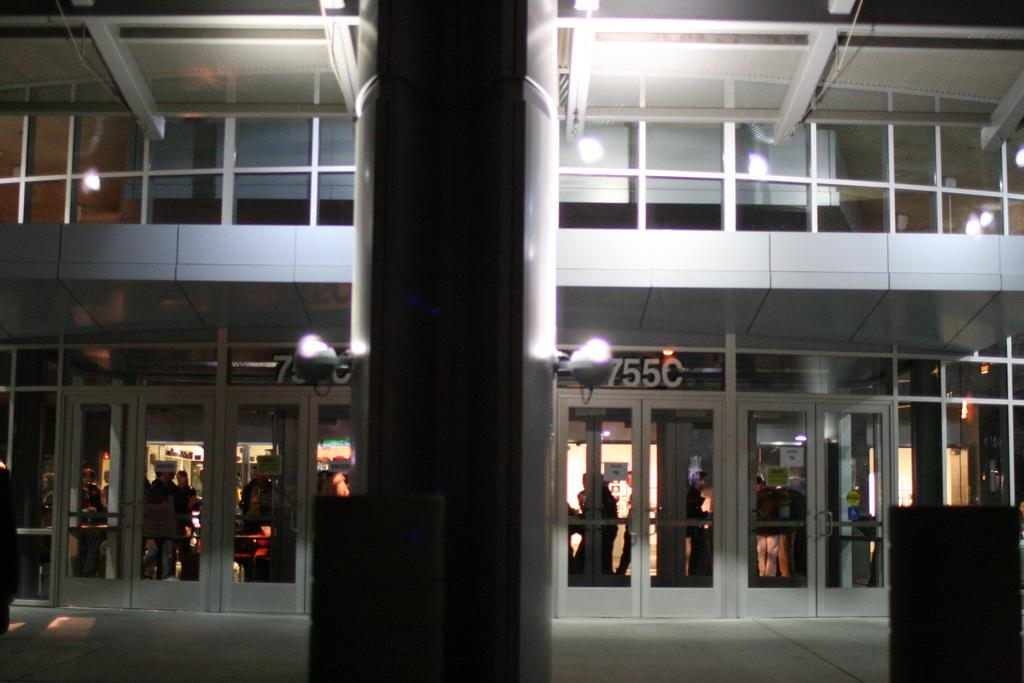What type of structure is visible in the image? There is a building in the image. What can be seen illuminating the scene in the image? There are lights in the image. Can you describe the people in the image? There is a group of people in the image. How many eggs are being held by the people in the image? There are no eggs visible in the image; the people are not holding any eggs. 